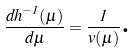Convert formula to latex. <formula><loc_0><loc_0><loc_500><loc_500>\frac { d h ^ { - 1 } ( \mu ) } { d \mu } = \frac { 1 } { v ( \mu ) } \text {.}</formula> 